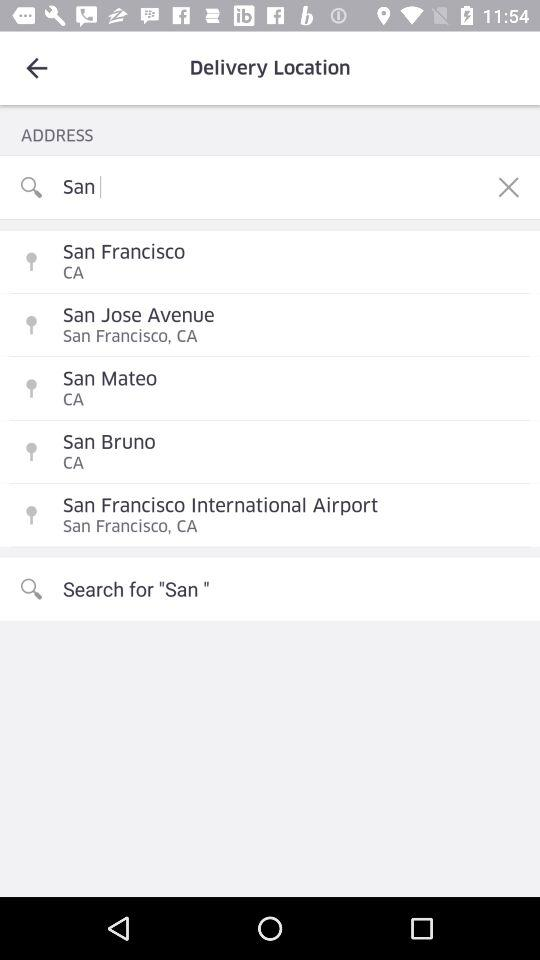What is the country name in search history?
When the provided information is insufficient, respond with <no answer>. <no answer> 